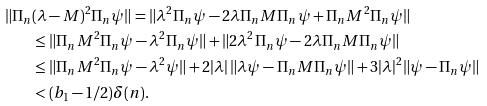Convert formula to latex. <formula><loc_0><loc_0><loc_500><loc_500>\| \Pi _ { n } & ( \lambda - M ) ^ { 2 } \Pi _ { n } \psi \| = \| \lambda ^ { 2 } \Pi _ { n } \psi - 2 \lambda \Pi _ { n } M \Pi _ { n } \psi + \Pi _ { n } M ^ { 2 } \Pi _ { n } \psi \| \\ & \leq \| \Pi _ { n } M ^ { 2 } \Pi _ { n } \psi - \lambda ^ { 2 } \Pi _ { n } \psi \| + \| 2 \lambda ^ { 2 } \Pi _ { n } \psi - 2 \lambda \Pi _ { n } M \Pi _ { n } \psi \| \\ & \leq \| \Pi _ { n } M ^ { 2 } \Pi _ { n } \psi - \lambda ^ { 2 } \psi \| + 2 | \lambda | \, \| \lambda \psi - \Pi _ { n } M \Pi _ { n } \psi \| + 3 | \lambda | ^ { 2 } \| \psi - \Pi _ { n } \psi \| \\ & < ( b _ { 1 } - 1 / 2 ) \delta ( n ) .</formula> 